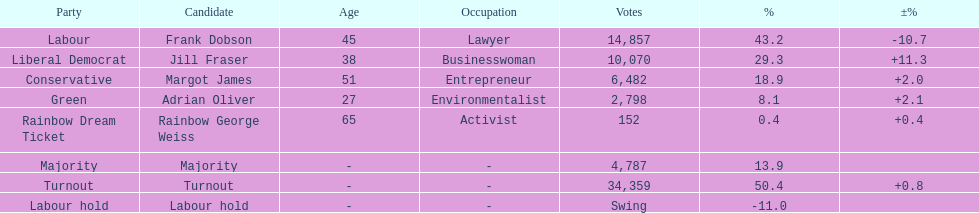How many votes did both the conservative party and the rainbow dream ticket party receive? 6634. 